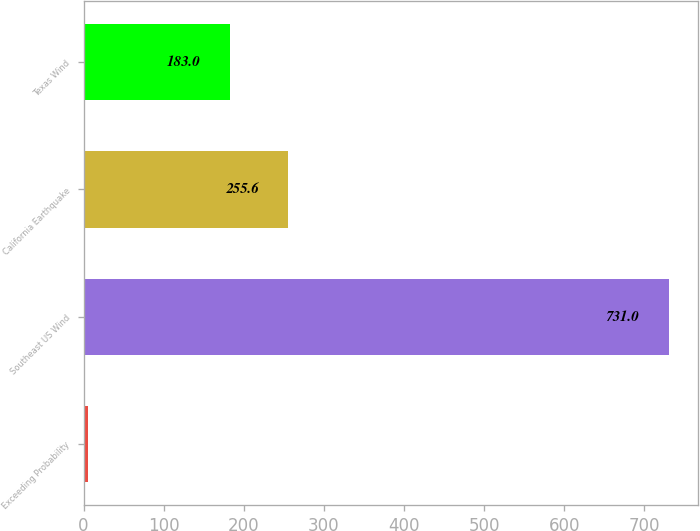<chart> <loc_0><loc_0><loc_500><loc_500><bar_chart><fcel>Exceeding Probability<fcel>Southeast US Wind<fcel>California Earthquake<fcel>Texas Wind<nl><fcel>5<fcel>731<fcel>255.6<fcel>183<nl></chart> 